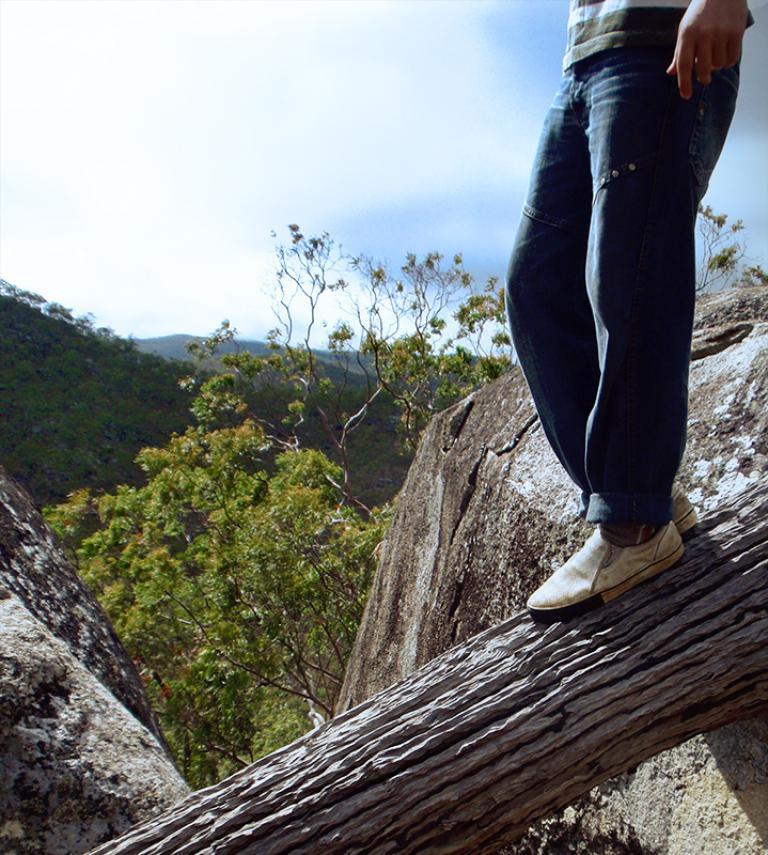How would you summarize this image in a sentence or two? In this image I can see a tree trunk in the front and on it I can see one person is standing. In the background I can see number of trees, mountains, clouds and the sky. I can see this person is wearing jeans and white shoes. 